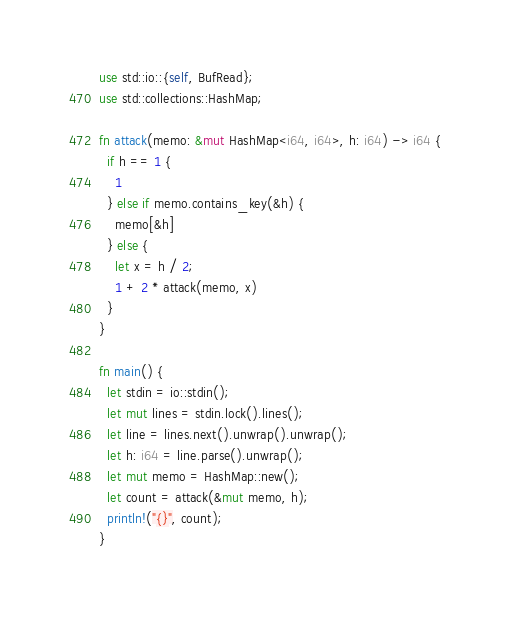<code> <loc_0><loc_0><loc_500><loc_500><_Rust_>use std::io::{self, BufRead};
use std::collections::HashMap;

fn attack(memo: &mut HashMap<i64, i64>, h: i64) -> i64 {
  if h == 1 {
    1
  } else if memo.contains_key(&h) {
    memo[&h]
  } else {
    let x = h / 2;
    1 + 2 * attack(memo, x)
  }
}

fn main() {
  let stdin = io::stdin();
  let mut lines = stdin.lock().lines();
  let line = lines.next().unwrap().unwrap();
  let h: i64 = line.parse().unwrap();
  let mut memo = HashMap::new();
  let count = attack(&mut memo, h);
  println!("{}", count);
}</code> 